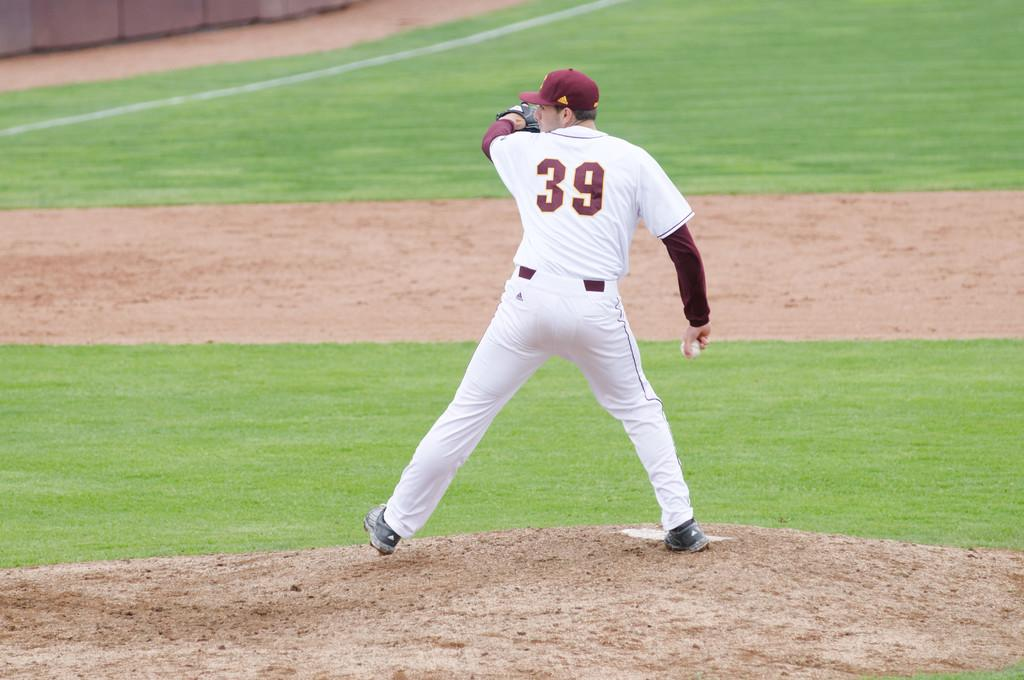<image>
Render a clear and concise summary of the photo. Player number 39 winds up in preparation to pitch the ball. 